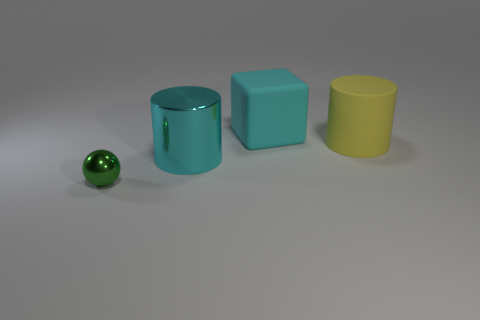Add 2 cyan rubber cylinders. How many objects exist? 6 Subtract all balls. How many objects are left? 3 Subtract 0 blue cubes. How many objects are left? 4 Subtract all tiny purple spheres. Subtract all large cyan shiny cylinders. How many objects are left? 3 Add 1 large yellow rubber cylinders. How many large yellow rubber cylinders are left? 2 Add 3 large cyan metallic cylinders. How many large cyan metallic cylinders exist? 4 